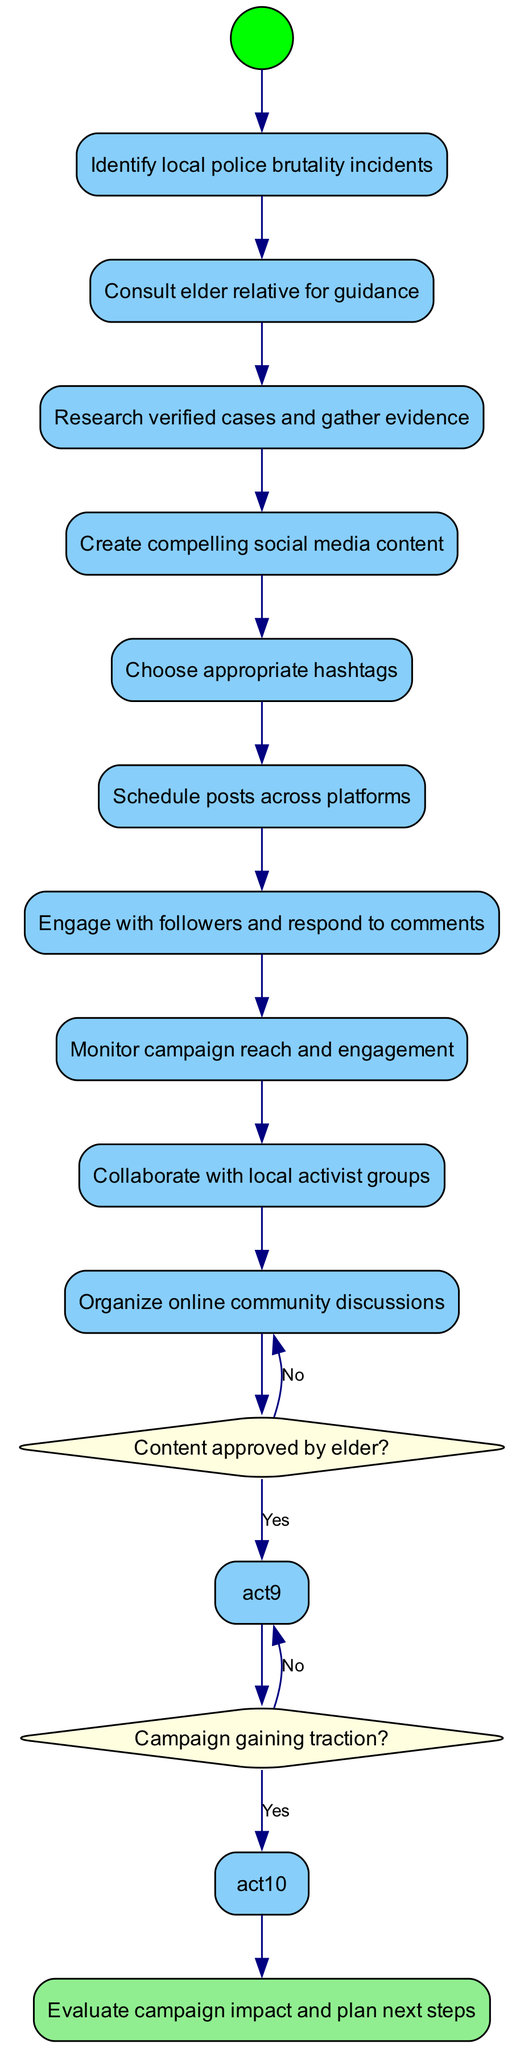What is the first activity in the diagram? The diagram starts with the initial node labeled "Identify local police brutality incidents," which represents the first activity to be undertaken.
Answer: Identify local police brutality incidents How many activities are listed in the diagram? Counting the activities provided, there are a total of nine activities listed, which includes actions such as consulting, researching, and creating content.
Answer: 9 What does the decision "Content approved by elder?" lead to if the answer is 'Yes'? If the answer to "Content approved by elder?" is 'Yes', the flow proceeds to the next action, which is "Proceed with posting," indicating that the approved content can be shared.
Answer: Proceed with posting What happens if the campaign is not gaining traction? If the campaign is not gaining traction, the decision "Campaign gaining traction?" directs the flow to "Adjust strategy," indicating a need to rethink the approach.
Answer: Adjust strategy What is the final outcome of the activity diagram? The last node in the diagram indicates the final outcome is to "Evaluate campaign impact and plan next steps," summarizing what should be done after executing the campaign.
Answer: Evaluate campaign impact and plan next steps Which activity immediately follows "Organize online community discussions"? The activity "Organize online community discussions" is followed by the decision node "Content approved by elder?" indicating that the decision-making process begins after organizing discussions.
Answer: Content approved by elder? How many decisions are present in the diagram? There are two decision nodes in the diagram, which ask about content approval and campaign traction, influencing the subsequent actions.
Answer: 2 What is required after "Research verified cases and gather evidence"? After "Research verified cases and gather evidence," the next activity is "Create compelling social media content," indicating the need to generate content based on the gathered evidence.
Answer: Create compelling social media content What is the purpose of the "Engage with followers and respond to comments" activity? This activity serves to maintain interaction with the audience, fostering community engagement and ensuring that comments and feedback from followers are addressed.
Answer: Community engagement 